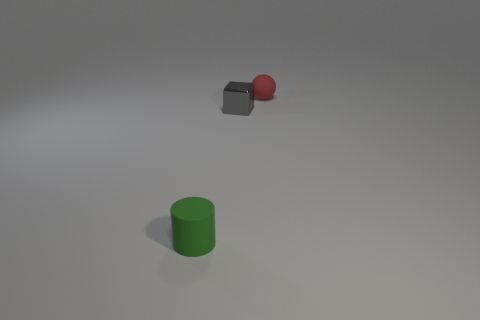Add 2 shiny spheres. How many objects exist? 5 Subtract all cylinders. How many objects are left? 2 Subtract all green metallic balls. Subtract all small green cylinders. How many objects are left? 2 Add 3 tiny red spheres. How many tiny red spheres are left? 4 Add 1 tiny red matte spheres. How many tiny red matte spheres exist? 2 Subtract 1 green cylinders. How many objects are left? 2 